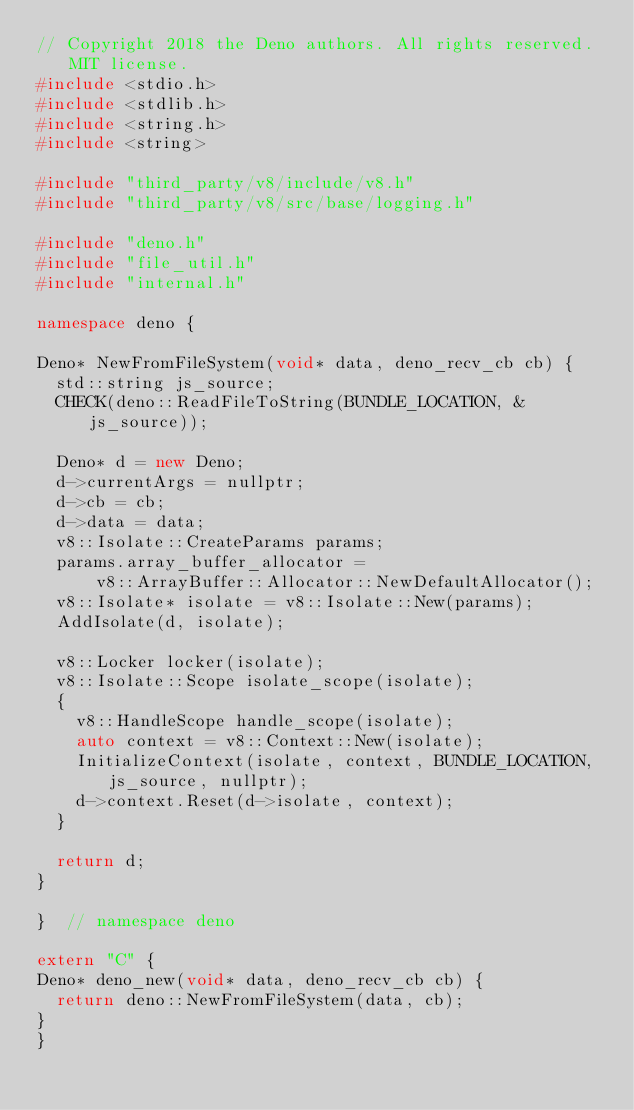Convert code to text. <code><loc_0><loc_0><loc_500><loc_500><_C++_>// Copyright 2018 the Deno authors. All rights reserved. MIT license.
#include <stdio.h>
#include <stdlib.h>
#include <string.h>
#include <string>

#include "third_party/v8/include/v8.h"
#include "third_party/v8/src/base/logging.h"

#include "deno.h"
#include "file_util.h"
#include "internal.h"

namespace deno {

Deno* NewFromFileSystem(void* data, deno_recv_cb cb) {
  std::string js_source;
  CHECK(deno::ReadFileToString(BUNDLE_LOCATION, &js_source));

  Deno* d = new Deno;
  d->currentArgs = nullptr;
  d->cb = cb;
  d->data = data;
  v8::Isolate::CreateParams params;
  params.array_buffer_allocator =
      v8::ArrayBuffer::Allocator::NewDefaultAllocator();
  v8::Isolate* isolate = v8::Isolate::New(params);
  AddIsolate(d, isolate);

  v8::Locker locker(isolate);
  v8::Isolate::Scope isolate_scope(isolate);
  {
    v8::HandleScope handle_scope(isolate);
    auto context = v8::Context::New(isolate);
    InitializeContext(isolate, context, BUNDLE_LOCATION, js_source, nullptr);
    d->context.Reset(d->isolate, context);
  }

  return d;
}

}  // namespace deno

extern "C" {
Deno* deno_new(void* data, deno_recv_cb cb) {
  return deno::NewFromFileSystem(data, cb);
}
}
</code> 